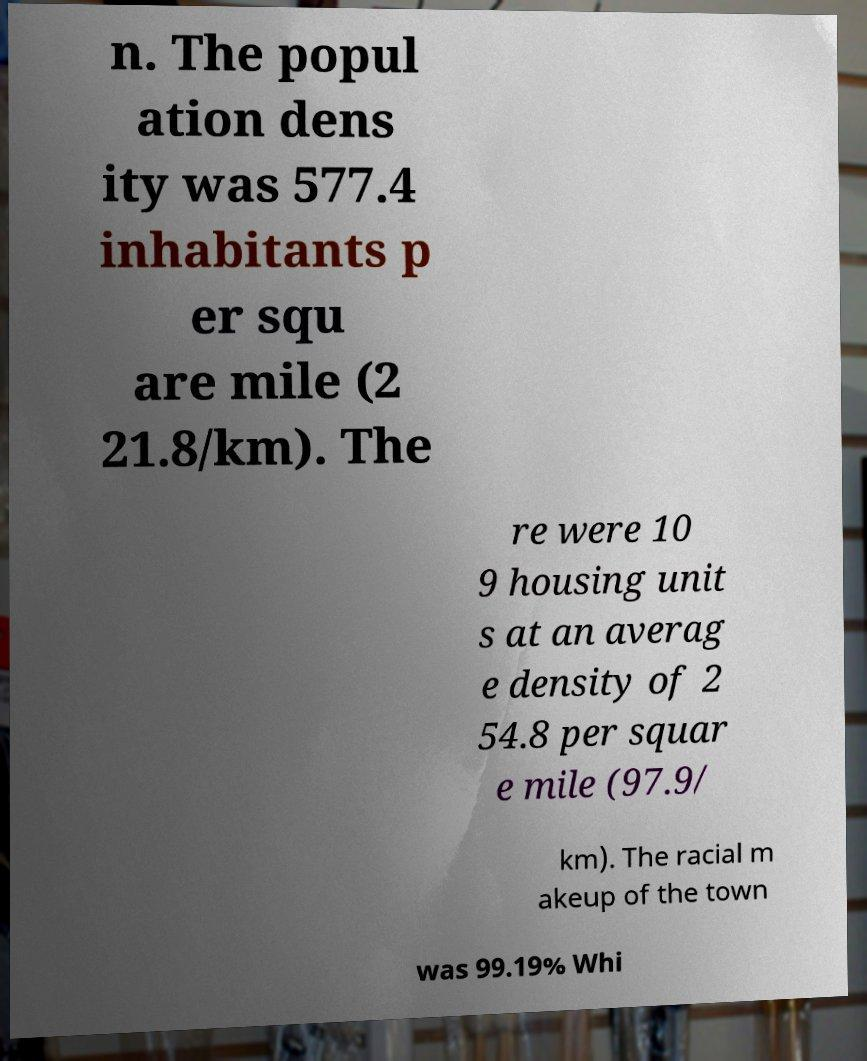Please read and relay the text visible in this image. What does it say? n. The popul ation dens ity was 577.4 inhabitants p er squ are mile (2 21.8/km). The re were 10 9 housing unit s at an averag e density of 2 54.8 per squar e mile (97.9/ km). The racial m akeup of the town was 99.19% Whi 